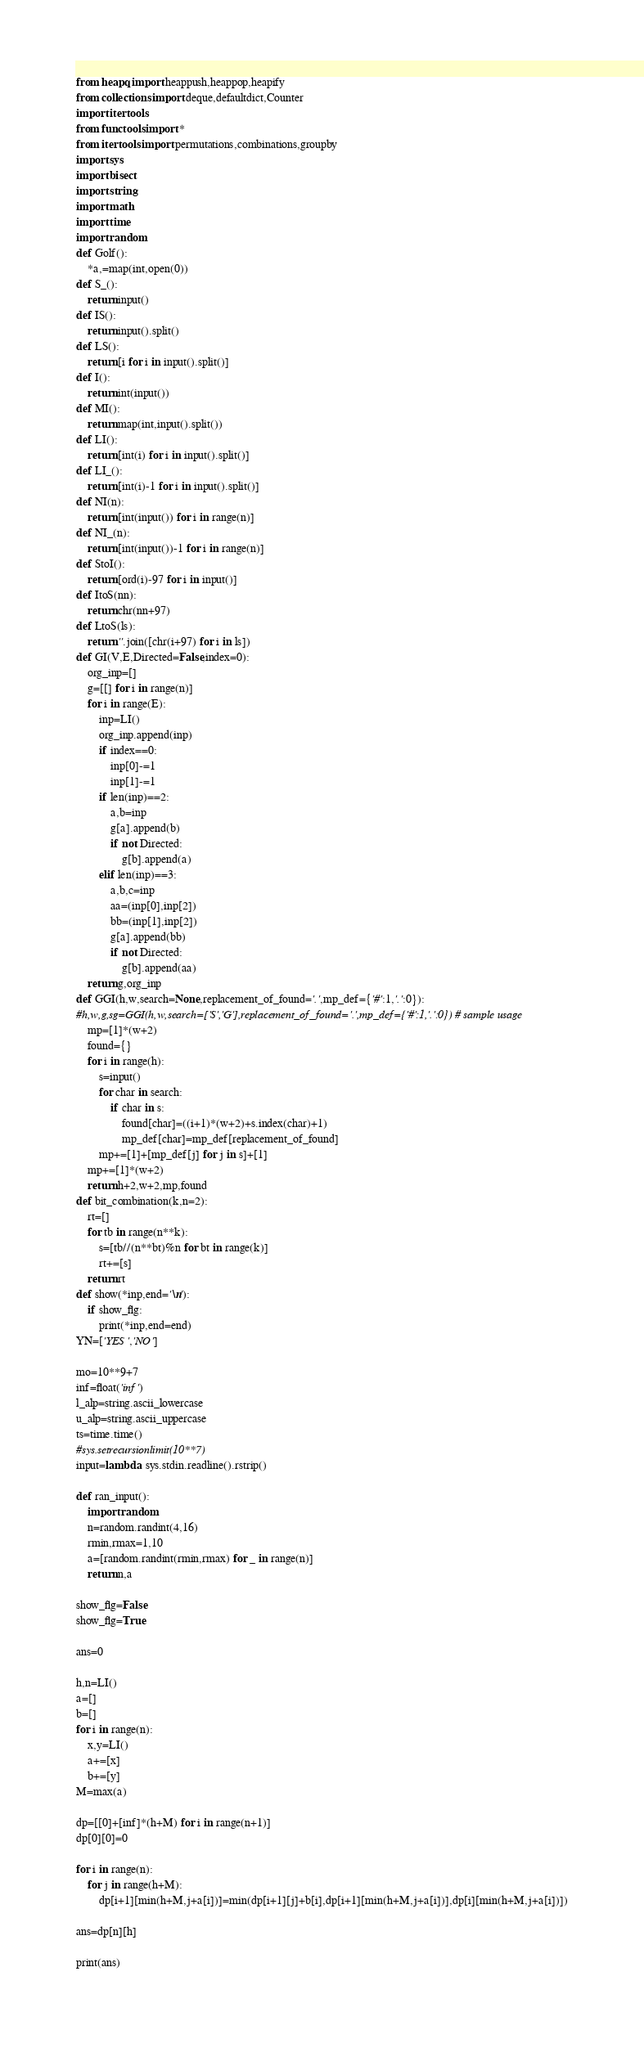<code> <loc_0><loc_0><loc_500><loc_500><_Python_>from heapq import heappush,heappop,heapify
from collections import deque,defaultdict,Counter
import itertools
from functools import *
from itertools import permutations,combinations,groupby
import sys
import bisect
import string
import math
import time
import random
def Golf():
    *a,=map(int,open(0))
def S_():
    return input()
def IS():
    return input().split()
def LS():
    return [i for i in input().split()]
def I():
    return int(input())
def MI():
    return map(int,input().split())
def LI():
    return [int(i) for i in input().split()]
def LI_():
    return [int(i)-1 for i in input().split()]
def NI(n):
    return [int(input()) for i in range(n)]
def NI_(n):
    return [int(input())-1 for i in range(n)]
def StoI():
    return [ord(i)-97 for i in input()]
def ItoS(nn):
    return chr(nn+97)
def LtoS(ls):
    return ''.join([chr(i+97) for i in ls])
def GI(V,E,Directed=False,index=0):
    org_inp=[]
    g=[[] for i in range(n)]
    for i in range(E):
        inp=LI()
        org_inp.append(inp)
        if index==0:
            inp[0]-=1
            inp[1]-=1
        if len(inp)==2:
            a,b=inp
            g[a].append(b)
            if not Directed:
                g[b].append(a)
        elif len(inp)==3:
            a,b,c=inp
            aa=(inp[0],inp[2])
            bb=(inp[1],inp[2])
            g[a].append(bb)
            if not Directed:
                g[b].append(aa)
    return g,org_inp
def GGI(h,w,search=None,replacement_of_found='.',mp_def={'#':1,'.':0}):
#h,w,g,sg=GGI(h,w,search=['S','G'],replacement_of_found='.',mp_def={'#':1,'.':0}) # sample usage
    mp=[1]*(w+2)
    found={}
    for i in range(h):
        s=input()
        for char in search:
            if char in s:
                found[char]=((i+1)*(w+2)+s.index(char)+1)
                mp_def[char]=mp_def[replacement_of_found]
        mp+=[1]+[mp_def[j] for j in s]+[1]
    mp+=[1]*(w+2)
    return h+2,w+2,mp,found
def bit_combination(k,n=2):
    rt=[]
    for tb in range(n**k):
        s=[tb//(n**bt)%n for bt in range(k)]
        rt+=[s]
    return rt
def show(*inp,end='\n'):
    if show_flg:
        print(*inp,end=end)
YN=['YES','NO']

mo=10**9+7
inf=float('inf')
l_alp=string.ascii_lowercase
u_alp=string.ascii_uppercase
ts=time.time()
#sys.setrecursionlimit(10**7)
input=lambda: sys.stdin.readline().rstrip()
 
def ran_input():
    import random
    n=random.randint(4,16)
    rmin,rmax=1,10
    a=[random.randint(rmin,rmax) for _ in range(n)]
    return n,a

show_flg=False
show_flg=True

ans=0

h,n=LI()
a=[]
b=[]
for i in range(n):
    x,y=LI()
    a+=[x]
    b+=[y]
M=max(a)

dp=[[0]+[inf]*(h+M) for i in range(n+1)]    
dp[0][0]=0

for i in range(n):
    for j in range(h+M):
        dp[i+1][min(h+M,j+a[i])]=min(dp[i+1][j]+b[i],dp[i+1][min(h+M,j+a[i])],dp[i][min(h+M,j+a[i])])

ans=dp[n][h]

print(ans)
</code> 